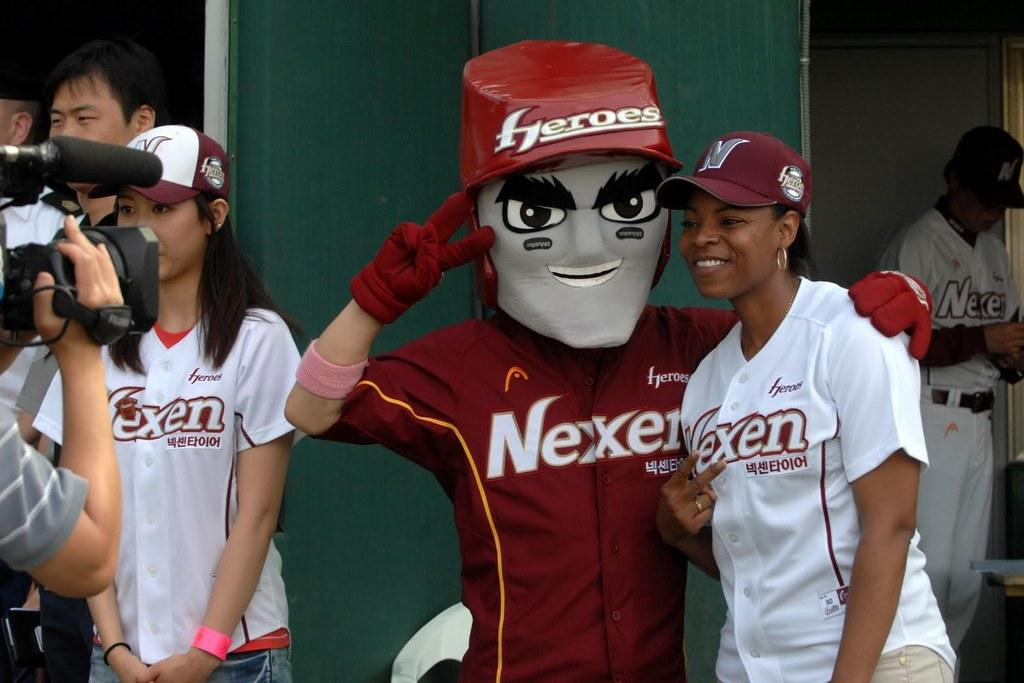<image>
Provide a brief description of the given image. A women poses with a mascot in a Heroes hat. 